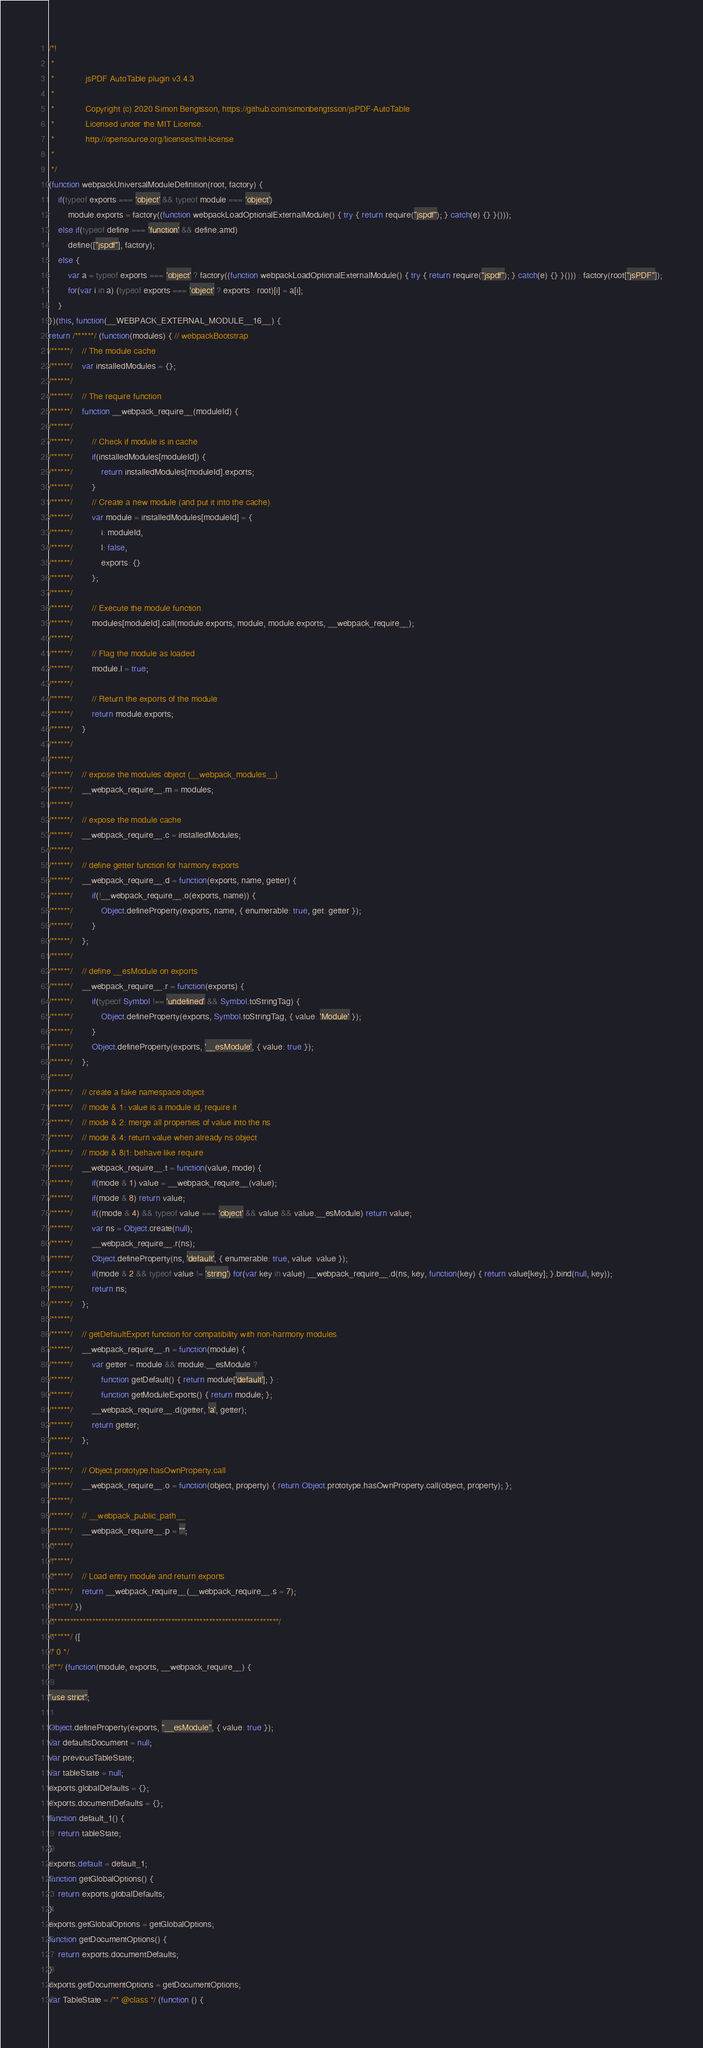<code> <loc_0><loc_0><loc_500><loc_500><_JavaScript_>/*!
 * 
 *             jsPDF AutoTable plugin v3.4.3
 *             
 *             Copyright (c) 2020 Simon Bengtsson, https://github.com/simonbengtsson/jsPDF-AutoTable
 *             Licensed under the MIT License.
 *             http://opensource.org/licenses/mit-license
 *         
 */
(function webpackUniversalModuleDefinition(root, factory) {
	if(typeof exports === 'object' && typeof module === 'object')
		module.exports = factory((function webpackLoadOptionalExternalModule() { try { return require("jspdf"); } catch(e) {} }()));
	else if(typeof define === 'function' && define.amd)
		define(["jspdf"], factory);
	else {
		var a = typeof exports === 'object' ? factory((function webpackLoadOptionalExternalModule() { try { return require("jspdf"); } catch(e) {} }())) : factory(root["jsPDF"]);
		for(var i in a) (typeof exports === 'object' ? exports : root)[i] = a[i];
	}
})(this, function(__WEBPACK_EXTERNAL_MODULE__16__) {
return /******/ (function(modules) { // webpackBootstrap
/******/ 	// The module cache
/******/ 	var installedModules = {};
/******/
/******/ 	// The require function
/******/ 	function __webpack_require__(moduleId) {
/******/
/******/ 		// Check if module is in cache
/******/ 		if(installedModules[moduleId]) {
/******/ 			return installedModules[moduleId].exports;
/******/ 		}
/******/ 		// Create a new module (and put it into the cache)
/******/ 		var module = installedModules[moduleId] = {
/******/ 			i: moduleId,
/******/ 			l: false,
/******/ 			exports: {}
/******/ 		};
/******/
/******/ 		// Execute the module function
/******/ 		modules[moduleId].call(module.exports, module, module.exports, __webpack_require__);
/******/
/******/ 		// Flag the module as loaded
/******/ 		module.l = true;
/******/
/******/ 		// Return the exports of the module
/******/ 		return module.exports;
/******/ 	}
/******/
/******/
/******/ 	// expose the modules object (__webpack_modules__)
/******/ 	__webpack_require__.m = modules;
/******/
/******/ 	// expose the module cache
/******/ 	__webpack_require__.c = installedModules;
/******/
/******/ 	// define getter function for harmony exports
/******/ 	__webpack_require__.d = function(exports, name, getter) {
/******/ 		if(!__webpack_require__.o(exports, name)) {
/******/ 			Object.defineProperty(exports, name, { enumerable: true, get: getter });
/******/ 		}
/******/ 	};
/******/
/******/ 	// define __esModule on exports
/******/ 	__webpack_require__.r = function(exports) {
/******/ 		if(typeof Symbol !== 'undefined' && Symbol.toStringTag) {
/******/ 			Object.defineProperty(exports, Symbol.toStringTag, { value: 'Module' });
/******/ 		}
/******/ 		Object.defineProperty(exports, '__esModule', { value: true });
/******/ 	};
/******/
/******/ 	// create a fake namespace object
/******/ 	// mode & 1: value is a module id, require it
/******/ 	// mode & 2: merge all properties of value into the ns
/******/ 	// mode & 4: return value when already ns object
/******/ 	// mode & 8|1: behave like require
/******/ 	__webpack_require__.t = function(value, mode) {
/******/ 		if(mode & 1) value = __webpack_require__(value);
/******/ 		if(mode & 8) return value;
/******/ 		if((mode & 4) && typeof value === 'object' && value && value.__esModule) return value;
/******/ 		var ns = Object.create(null);
/******/ 		__webpack_require__.r(ns);
/******/ 		Object.defineProperty(ns, 'default', { enumerable: true, value: value });
/******/ 		if(mode & 2 && typeof value != 'string') for(var key in value) __webpack_require__.d(ns, key, function(key) { return value[key]; }.bind(null, key));
/******/ 		return ns;
/******/ 	};
/******/
/******/ 	// getDefaultExport function for compatibility with non-harmony modules
/******/ 	__webpack_require__.n = function(module) {
/******/ 		var getter = module && module.__esModule ?
/******/ 			function getDefault() { return module['default']; } :
/******/ 			function getModuleExports() { return module; };
/******/ 		__webpack_require__.d(getter, 'a', getter);
/******/ 		return getter;
/******/ 	};
/******/
/******/ 	// Object.prototype.hasOwnProperty.call
/******/ 	__webpack_require__.o = function(object, property) { return Object.prototype.hasOwnProperty.call(object, property); };
/******/
/******/ 	// __webpack_public_path__
/******/ 	__webpack_require__.p = "";
/******/
/******/
/******/ 	// Load entry module and return exports
/******/ 	return __webpack_require__(__webpack_require__.s = 7);
/******/ })
/************************************************************************/
/******/ ([
/* 0 */
/***/ (function(module, exports, __webpack_require__) {

"use strict";

Object.defineProperty(exports, "__esModule", { value: true });
var defaultsDocument = null;
var previousTableState;
var tableState = null;
exports.globalDefaults = {};
exports.documentDefaults = {};
function default_1() {
    return tableState;
}
exports.default = default_1;
function getGlobalOptions() {
    return exports.globalDefaults;
}
exports.getGlobalOptions = getGlobalOptions;
function getDocumentOptions() {
    return exports.documentDefaults;
}
exports.getDocumentOptions = getDocumentOptions;
var TableState = /** @class */ (function () {</code> 